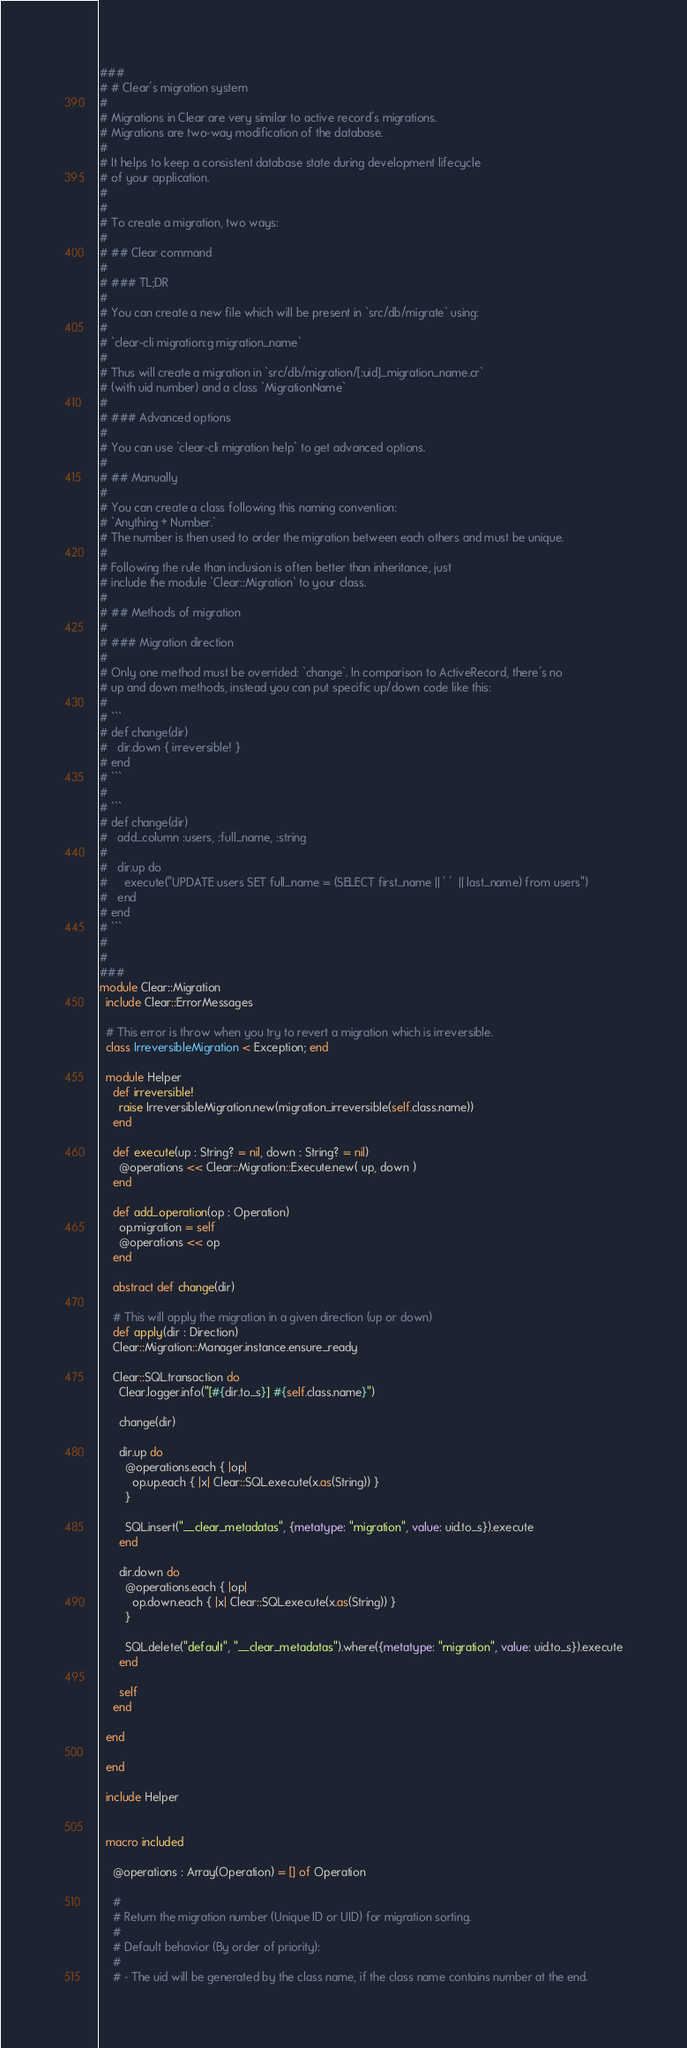<code> <loc_0><loc_0><loc_500><loc_500><_Crystal_>###
# # Clear's migration system
#
# Migrations in Clear are very similar to active record's migrations.
# Migrations are two-way modification of the database.
#
# It helps to keep a consistent database state during development lifecycle
# of your application.
#
#
# To create a migration, two ways:
#
# ## Clear command
#
# ### TL;DR
#
# You can create a new file which will be present in `src/db/migrate` using:
#
# `clear-cli migration:g migration_name`
#
# Thus will create a migration in `src/db/migration/[:uid]_migration_name.cr`
# (with uid number) and a class `MigrationName`
#
# ### Advanced options
#
# You can use `clear-cli migration help` to get advanced options.
#
# ## Manually
#
# You can create a class following this naming convention:
# `Anything + Number.`
# The number is then used to order the migration between each others and must be unique.
#
# Following the rule than inclusion is often better than inheritance, just
# include the module `Clear::Migration` to your class.
#
# ## Methods of migration
#
# ### Migration direction
#
# Only one method must be overrided: `change`. In comparison to ActiveRecord, there's no
# up and down methods, instead you can put specific up/down code like this:
#
# ```
# def change(dir)
#   dir.down { irreversible! }
# end
# ```
#
# ```
# def change(dir)
#   add_column :users, :full_name, :string
#
#   dir.up do
#     execute("UPDATE users SET full_name = (SELECT first_name || ' '  || last_name) from users")
#   end
# end
# ```
#
#
###
module Clear::Migration
  include Clear::ErrorMessages

  # This error is throw when you try to revert a migration which is irreversible.
  class IrreversibleMigration < Exception; end

  module Helper
    def irreversible!
      raise IrreversibleMigration.new(migration_irreversible(self.class.name))
    end

    def execute(up : String? = nil, down : String? = nil)
      @operations << Clear::Migration::Execute.new( up, down )
    end

    def add_operation(op : Operation)
      op.migration = self
      @operations << op
    end

    abstract def change(dir)

    # This will apply the migration in a given direction (up or down)
    def apply(dir : Direction)
    Clear::Migration::Manager.instance.ensure_ready

    Clear::SQL.transaction do
      Clear.logger.info("[#{dir.to_s}] #{self.class.name}")

      change(dir)

      dir.up do
        @operations.each { |op|
          op.up.each { |x| Clear::SQL.execute(x.as(String)) }
        }

        SQL.insert("__clear_metadatas", {metatype: "migration", value: uid.to_s}).execute
      end

      dir.down do
        @operations.each { |op|
          op.down.each { |x| Clear::SQL.execute(x.as(String)) }
        }

        SQL.delete("default", "__clear_metadatas").where({metatype: "migration", value: uid.to_s}).execute
      end

      self
    end

  end

  end

  include Helper


  macro included

    @operations : Array(Operation) = [] of Operation

    #
    # Return the migration number (Unique ID or UID) for migration sorting.
    #
    # Default behavior (By order of priority):
    #
    # - The uid will be generated by the class name, if the class name contains number at the end.</code> 